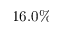<formula> <loc_0><loc_0><loc_500><loc_500>1 6 . 0 \%</formula> 